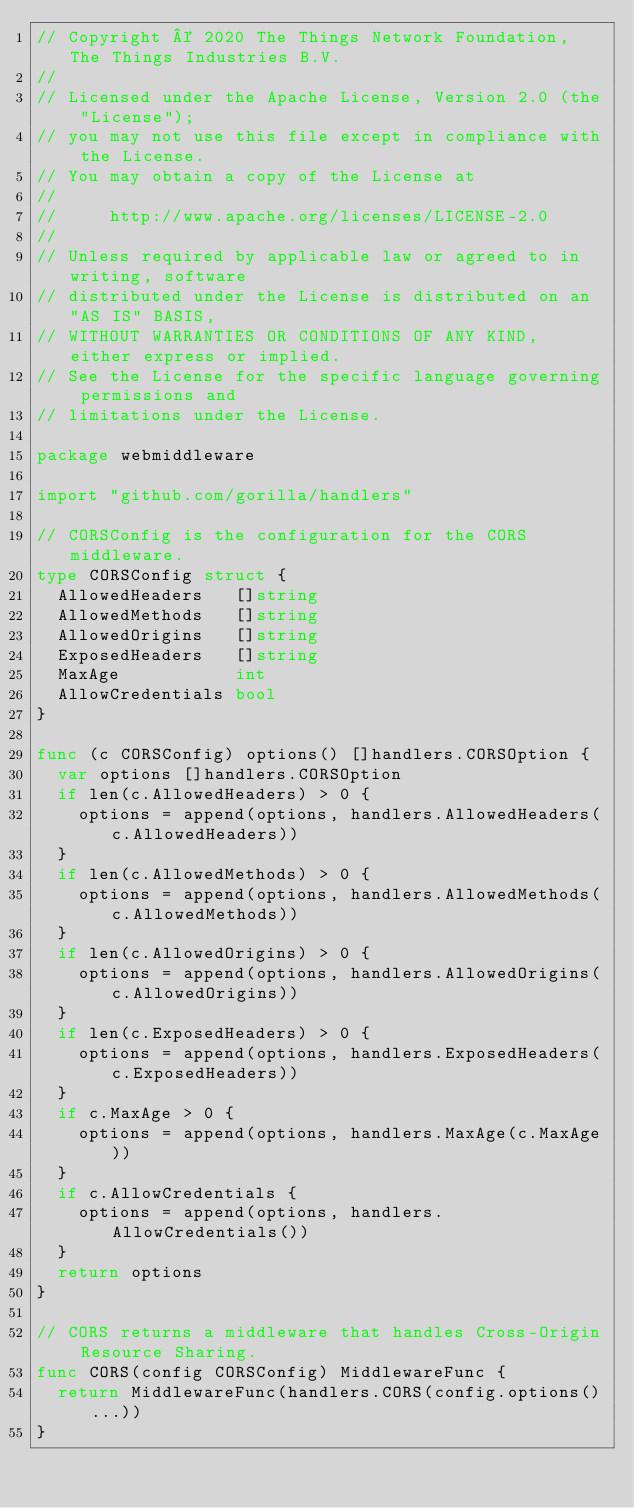<code> <loc_0><loc_0><loc_500><loc_500><_Go_>// Copyright © 2020 The Things Network Foundation, The Things Industries B.V.
//
// Licensed under the Apache License, Version 2.0 (the "License");
// you may not use this file except in compliance with the License.
// You may obtain a copy of the License at
//
//     http://www.apache.org/licenses/LICENSE-2.0
//
// Unless required by applicable law or agreed to in writing, software
// distributed under the License is distributed on an "AS IS" BASIS,
// WITHOUT WARRANTIES OR CONDITIONS OF ANY KIND, either express or implied.
// See the License for the specific language governing permissions and
// limitations under the License.

package webmiddleware

import "github.com/gorilla/handlers"

// CORSConfig is the configuration for the CORS middleware.
type CORSConfig struct {
	AllowedHeaders   []string
	AllowedMethods   []string
	AllowedOrigins   []string
	ExposedHeaders   []string
	MaxAge           int
	AllowCredentials bool
}

func (c CORSConfig) options() []handlers.CORSOption {
	var options []handlers.CORSOption
	if len(c.AllowedHeaders) > 0 {
		options = append(options, handlers.AllowedHeaders(c.AllowedHeaders))
	}
	if len(c.AllowedMethods) > 0 {
		options = append(options, handlers.AllowedMethods(c.AllowedMethods))
	}
	if len(c.AllowedOrigins) > 0 {
		options = append(options, handlers.AllowedOrigins(c.AllowedOrigins))
	}
	if len(c.ExposedHeaders) > 0 {
		options = append(options, handlers.ExposedHeaders(c.ExposedHeaders))
	}
	if c.MaxAge > 0 {
		options = append(options, handlers.MaxAge(c.MaxAge))
	}
	if c.AllowCredentials {
		options = append(options, handlers.AllowCredentials())
	}
	return options
}

// CORS returns a middleware that handles Cross-Origin Resource Sharing.
func CORS(config CORSConfig) MiddlewareFunc {
	return MiddlewareFunc(handlers.CORS(config.options()...))
}
</code> 